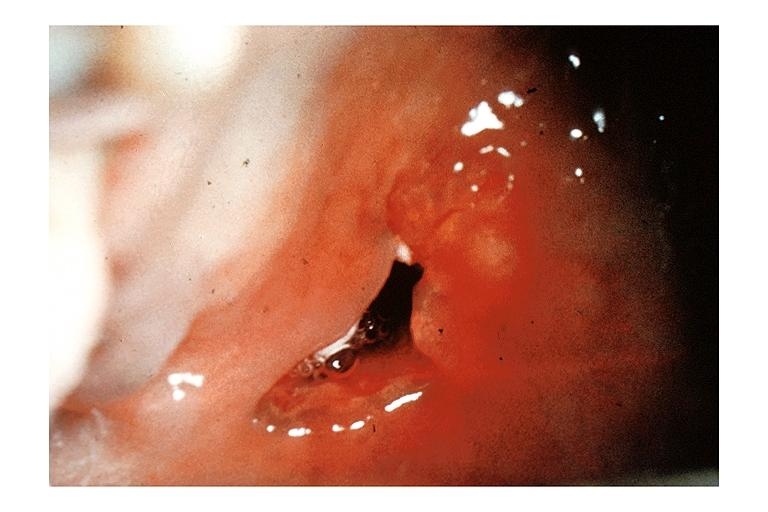what is present?
Answer the question using a single word or phrase. Oral 